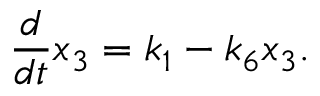<formula> <loc_0><loc_0><loc_500><loc_500>\frac { d } { d t } x _ { 3 } = k _ { 1 } - k _ { 6 } x _ { 3 } .</formula> 